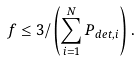<formula> <loc_0><loc_0><loc_500><loc_500>f \leq 3 / \left ( \sum _ { i = 1 } ^ { N } P _ { d e t , i } \right ) .</formula> 